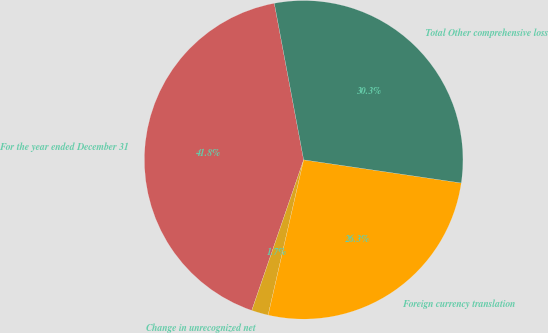Convert chart. <chart><loc_0><loc_0><loc_500><loc_500><pie_chart><fcel>For the year ended December 31<fcel>Change in unrecognized net<fcel>Foreign currency translation<fcel>Total Other comprehensive loss<nl><fcel>41.77%<fcel>1.7%<fcel>26.26%<fcel>30.27%<nl></chart> 